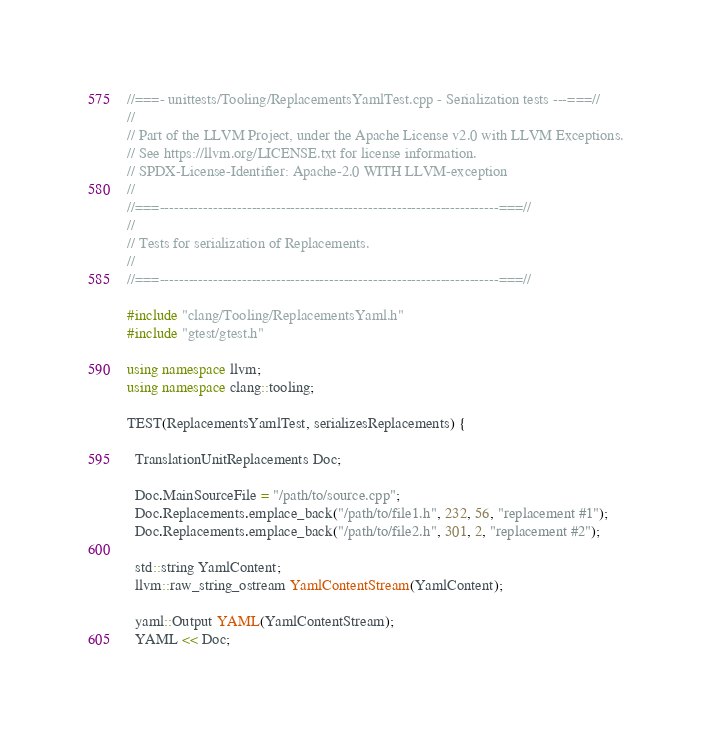Convert code to text. <code><loc_0><loc_0><loc_500><loc_500><_C++_>//===- unittests/Tooling/ReplacementsYamlTest.cpp - Serialization tests ---===//
//
// Part of the LLVM Project, under the Apache License v2.0 with LLVM Exceptions.
// See https://llvm.org/LICENSE.txt for license information.
// SPDX-License-Identifier: Apache-2.0 WITH LLVM-exception
//
//===----------------------------------------------------------------------===//
//
// Tests for serialization of Replacements.
//
//===----------------------------------------------------------------------===//

#include "clang/Tooling/ReplacementsYaml.h"
#include "gtest/gtest.h"

using namespace llvm;
using namespace clang::tooling;

TEST(ReplacementsYamlTest, serializesReplacements) {

  TranslationUnitReplacements Doc;

  Doc.MainSourceFile = "/path/to/source.cpp";
  Doc.Replacements.emplace_back("/path/to/file1.h", 232, 56, "replacement #1");
  Doc.Replacements.emplace_back("/path/to/file2.h", 301, 2, "replacement #2");

  std::string YamlContent;
  llvm::raw_string_ostream YamlContentStream(YamlContent);

  yaml::Output YAML(YamlContentStream);
  YAML << Doc;
</code> 